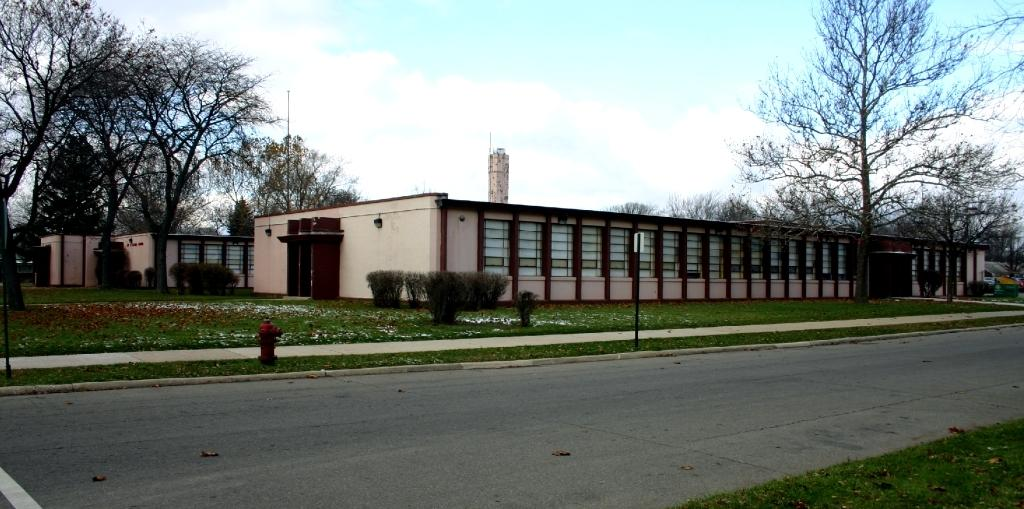What type of surface can be seen in the image? There is a road in the image. What type of vegetation is present in the image? There is grass, plants, and trees in the image. What type of structure is present in the image? There is a hydrant and buildings in the image. What else can be seen in the image? There are objects in the image. What is visible in the background of the image? The sky is visible in the background of the image. What can be seen in the sky? There are clouds in the sky. How many cents are visible on the road in the image? There are no cents present on the road in the image. Is there a boy playing with a steam engine in the image? There is no boy or steam engine present in the image. 